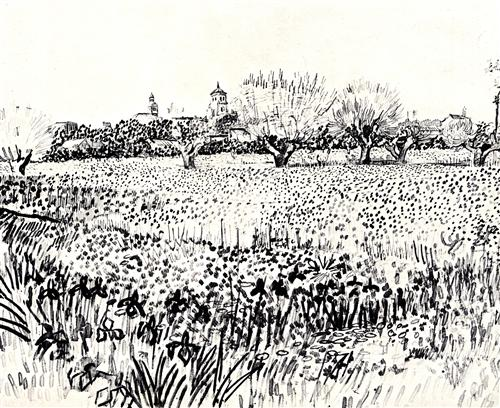What time of year do you think this scene depicts? Given the bare branches of the trees and the detailed depiction of wildflowers, it seems likely that this scene takes place in early spring or late autumn. The flowers suggest a time when the landscape is starting to bloom, but the bare trees hint at the remnants of winter or the beginning of a cooler season. 